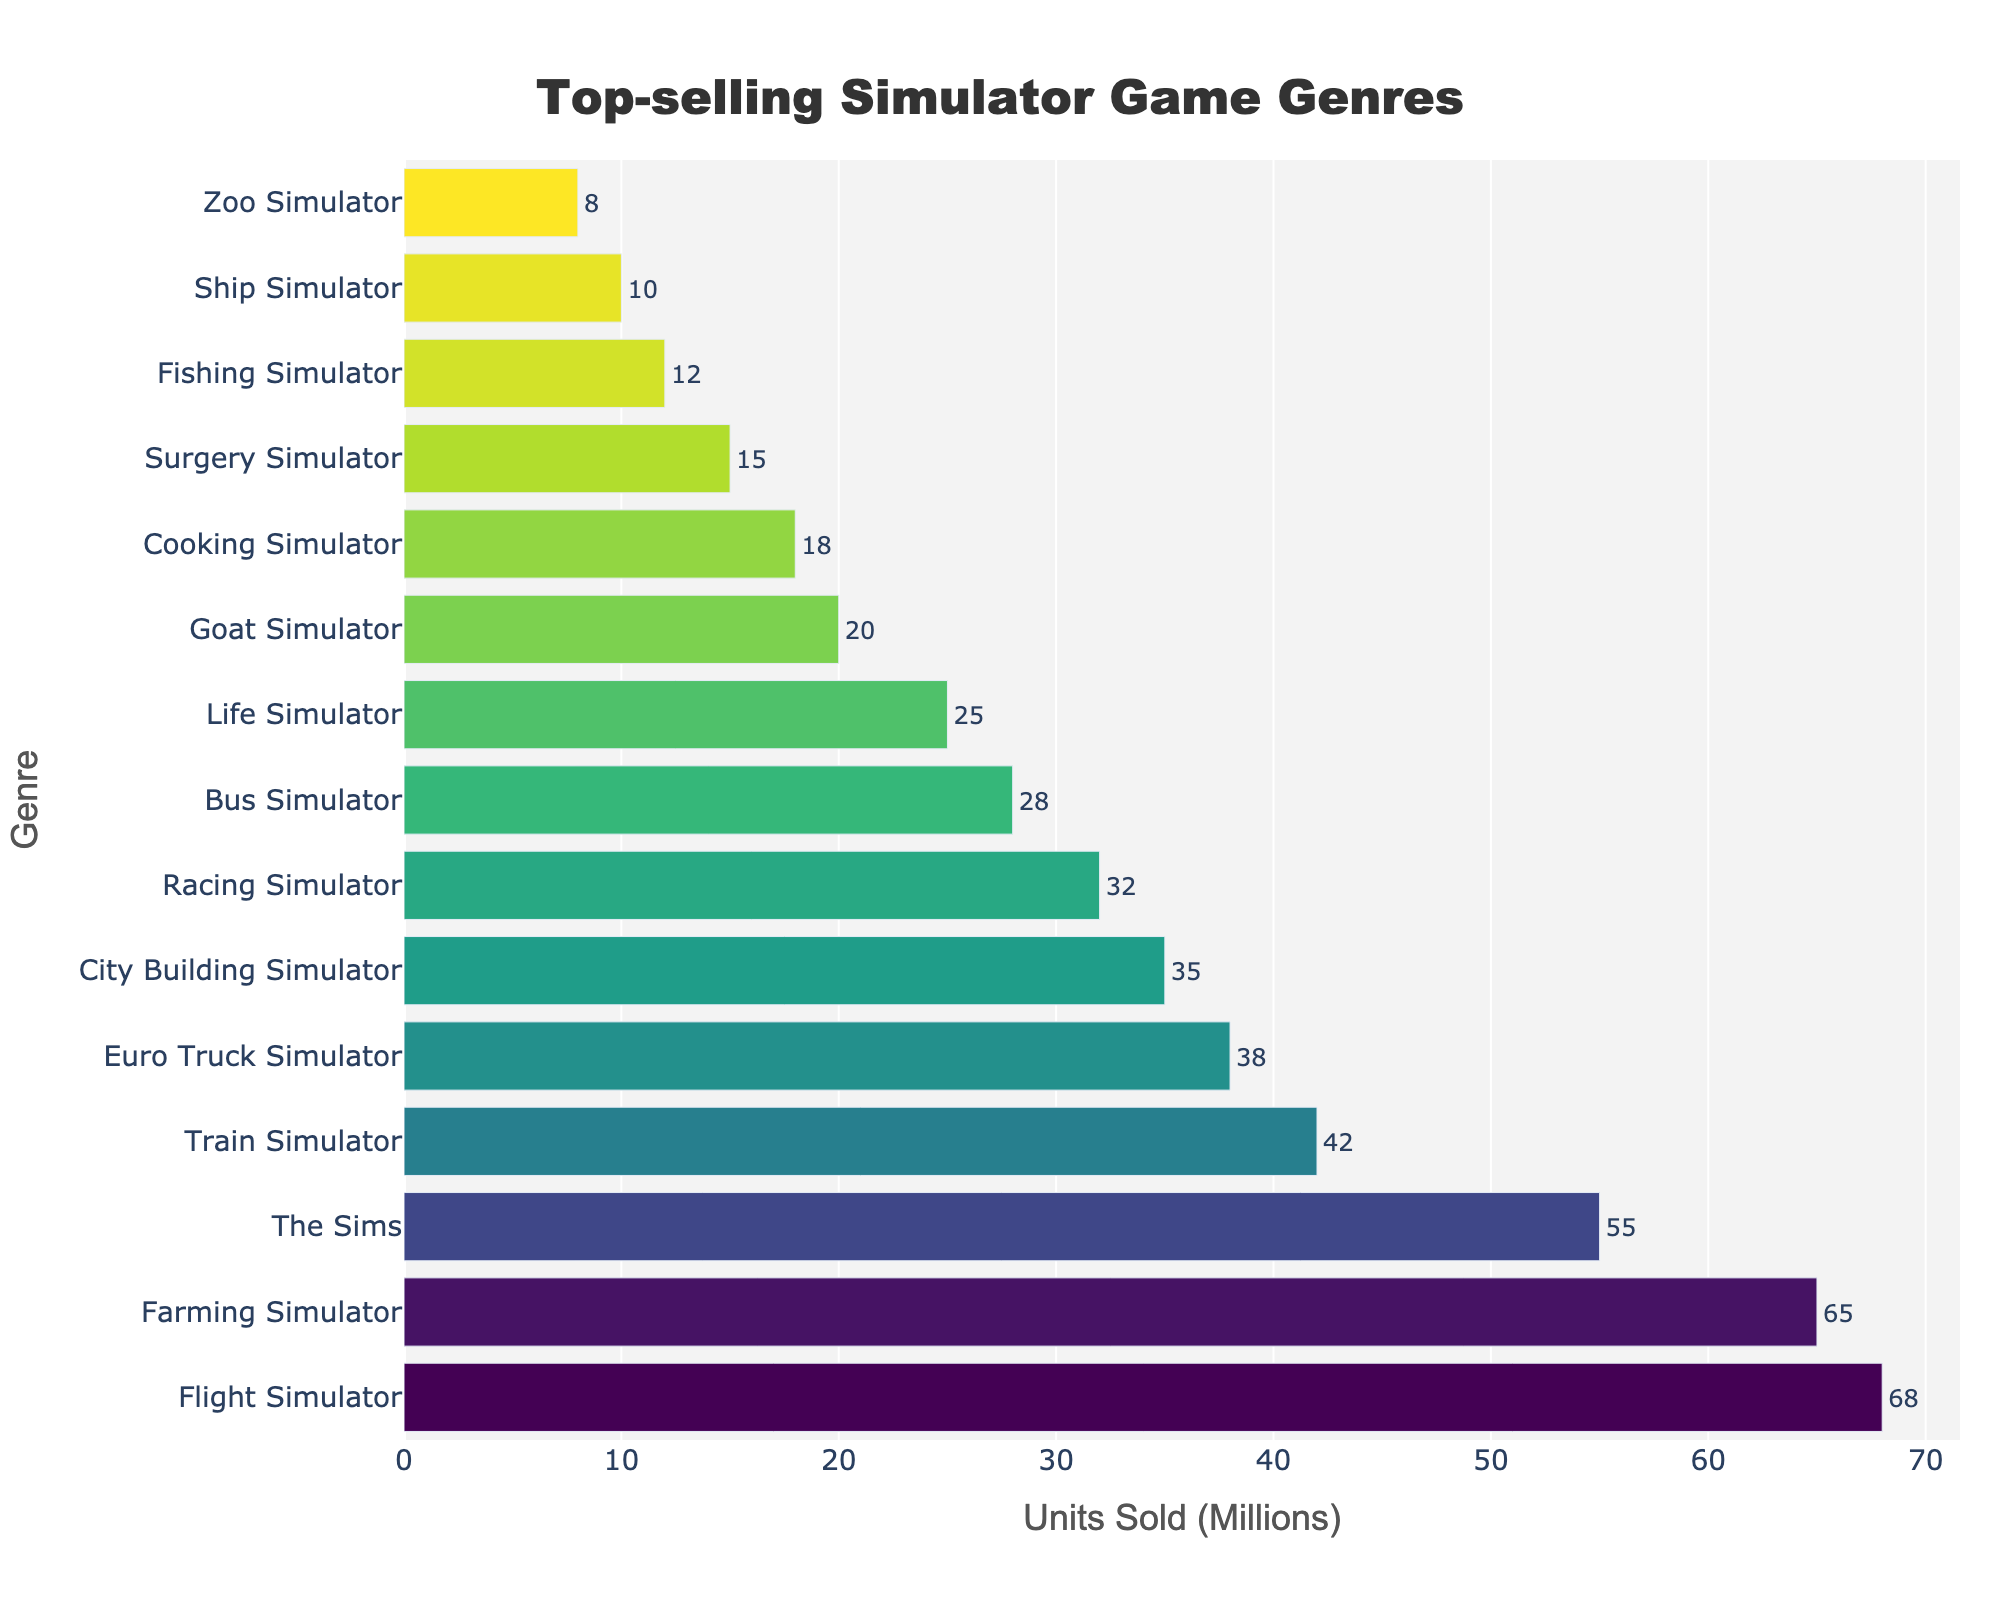Which simulator genre sold the most units? The bar representing "Flight Simulator" has the longest length, indicating it sold the most units.
Answer: Flight Simulator How many more units did Flight Simulator sell compared to Bus Simulator? Flight Simulator sold 68 million units, while Bus Simulator sold 28 million. The difference is 68 - 28 = 40 million units.
Answer: 40 million Which genre sold more units: Train Simulator or Euro Truck Simulator? The bar for Train Simulator is longer than the bar for Euro Truck Simulator, indicating it sold more units.
Answer: Train Simulator What is the combined units sold for the top three genres? The top three genres are Flight Simulator (68 million), Farming Simulator (65 million), and The Sims (55 million). Their combined units sold is 68 + 65 + 55 = 188 million units.
Answer: 188 million Which genre has a bar color closest to green? The City Building Simulator bar appears closest to green based on the Viridis colorscale used.
Answer: City Building Simulator How many genres sold more than 30 million units? Counting the genres with bars longer than the 30 million mark, we have: Flight Simulator, Farming Simulator, The Sims, Train Simulator, and Euro Truck Simulator. So, there are 5 genres.
Answer: 5 What is the total units sold for Bus Simulator, Life Simulator, and Goat Simulator combined? Bus Simulator sold 28 million, Life Simulator sold 25 million, and Goat Simulator sold 20 million. Their combined total is 28 + 25 + 20 = 73 million units.
Answer: 73 million Is the units sold for Surgery Simulator greater than that for Fishing Simulator? The bar for Surgery Simulator is longer than the bar for Fishing Simulator, indicating it sold more units.
Answer: Yes Which genre is at the median position in terms of units sold? With 15 genres, the median position is the 8th. The 8th genre is Bus Simulator.
Answer: Bus Simulator What's the difference in units sold between the genre with the least sales and the genre with the most sales? The genre with the least sales is Zoo Simulator with 8 million units, and the genre with the most sales is Flight Simulator with 68 million units. The difference is 68 - 8 = 60 million units.
Answer: 60 million 